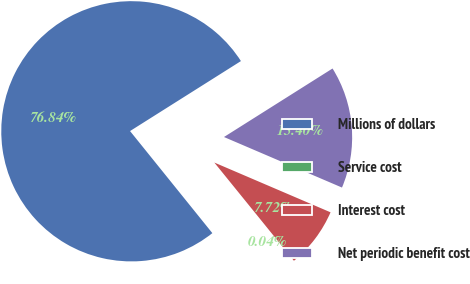Convert chart. <chart><loc_0><loc_0><loc_500><loc_500><pie_chart><fcel>Millions of dollars<fcel>Service cost<fcel>Interest cost<fcel>Net periodic benefit cost<nl><fcel>76.84%<fcel>0.04%<fcel>7.72%<fcel>15.4%<nl></chart> 